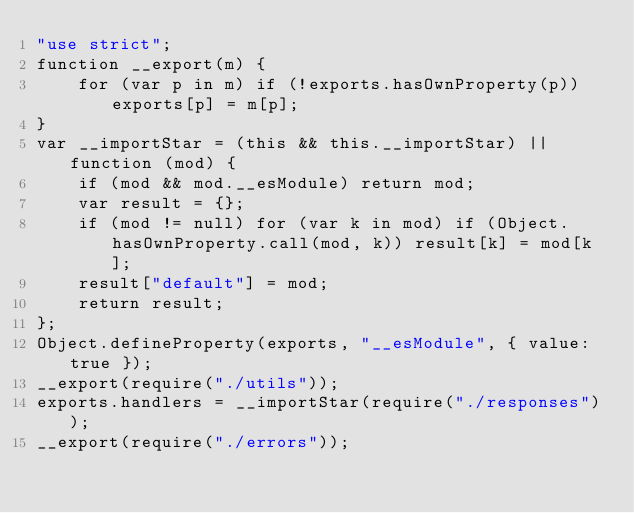<code> <loc_0><loc_0><loc_500><loc_500><_JavaScript_>"use strict";
function __export(m) {
    for (var p in m) if (!exports.hasOwnProperty(p)) exports[p] = m[p];
}
var __importStar = (this && this.__importStar) || function (mod) {
    if (mod && mod.__esModule) return mod;
    var result = {};
    if (mod != null) for (var k in mod) if (Object.hasOwnProperty.call(mod, k)) result[k] = mod[k];
    result["default"] = mod;
    return result;
};
Object.defineProperty(exports, "__esModule", { value: true });
__export(require("./utils"));
exports.handlers = __importStar(require("./responses"));
__export(require("./errors"));</code> 